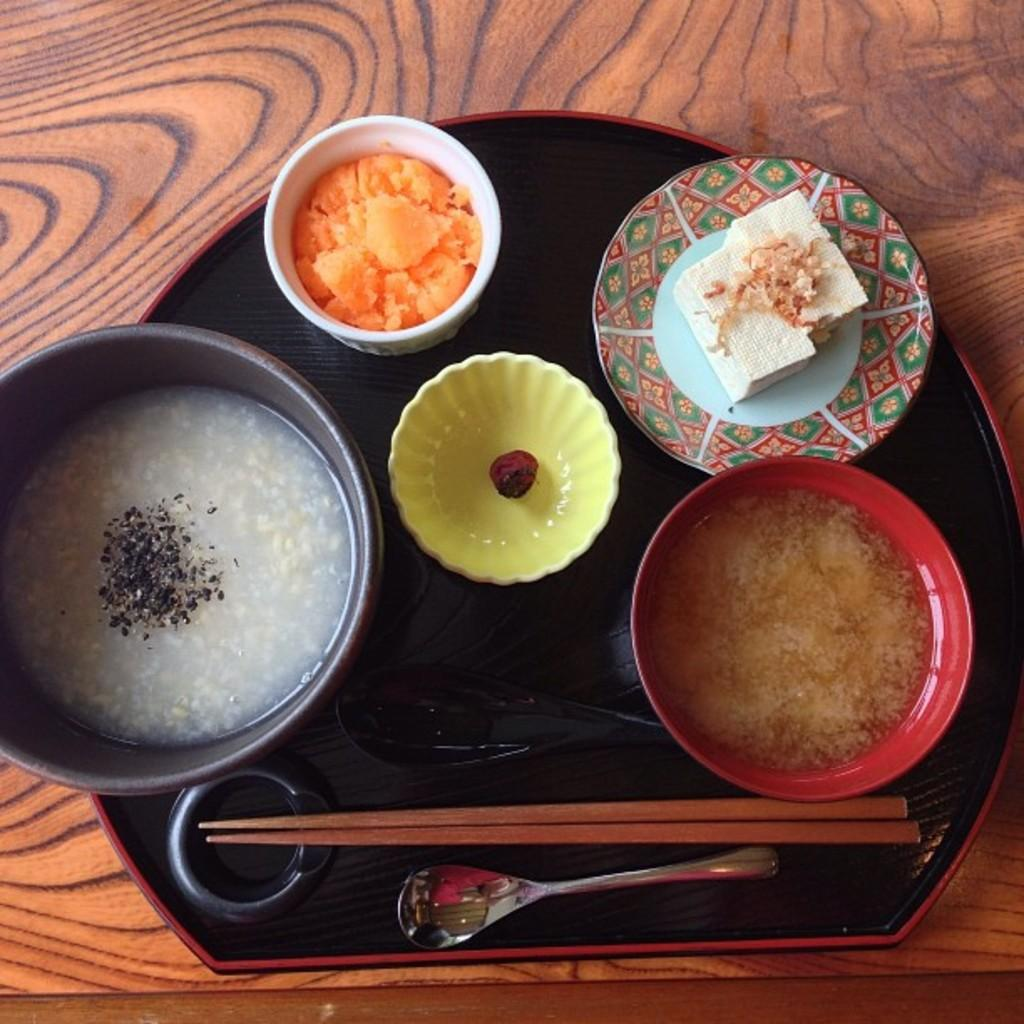What type of surface is visible in the image? There is a wooden surface in the image. What is placed on the wooden surface? There is a platter on the wooden surface. What is located above the platter? Above the platter, there is a plate, bowls, chopsticks, spoons, and food. Can you see any twigs or screws on the wooden surface in the image? No, there are no twigs or screws visible on the wooden surface in the image. 